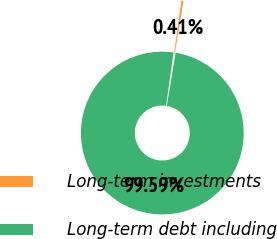<chart> <loc_0><loc_0><loc_500><loc_500><pie_chart><fcel>Long-term investments<fcel>Long-term debt including<nl><fcel>0.41%<fcel>99.59%<nl></chart> 